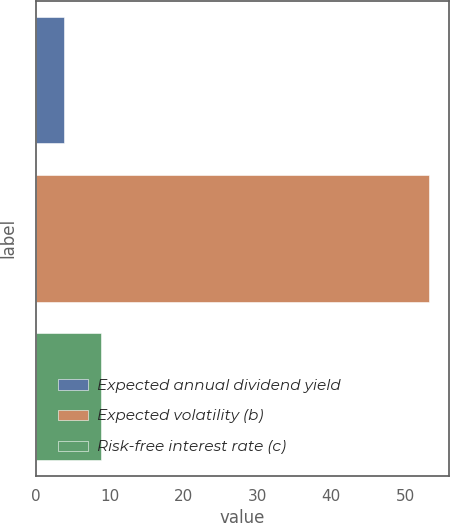Convert chart to OTSL. <chart><loc_0><loc_0><loc_500><loc_500><bar_chart><fcel>Expected annual dividend yield<fcel>Expected volatility (b)<fcel>Risk-free interest rate (c)<nl><fcel>3.77<fcel>53.27<fcel>8.72<nl></chart> 